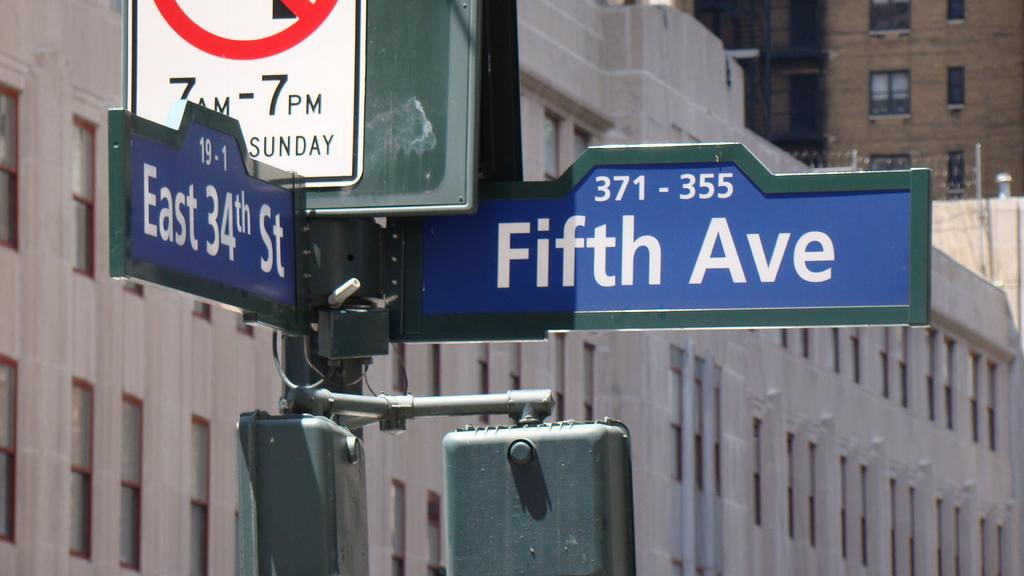Provide a one-sentence caption for the provided image. a close up of a sign for Fifth Ave 371-355. 